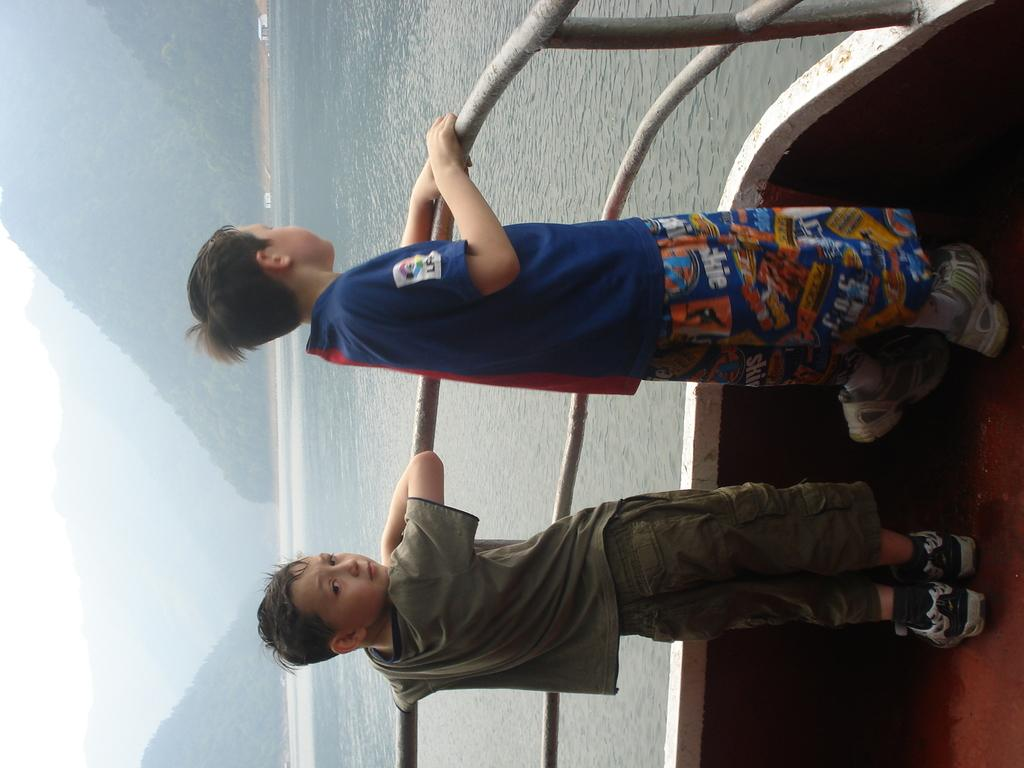What is the main subject of the image? The main subject of the image is kids standing on the floor. What can be seen in the image besides the kids? There is a railing in the image. What is visible in the background of the image? Water and hills are visible in the background of the image. What type of care is being provided to the kids in the image? There is no indication in the image that the kids are receiving any specific care. 